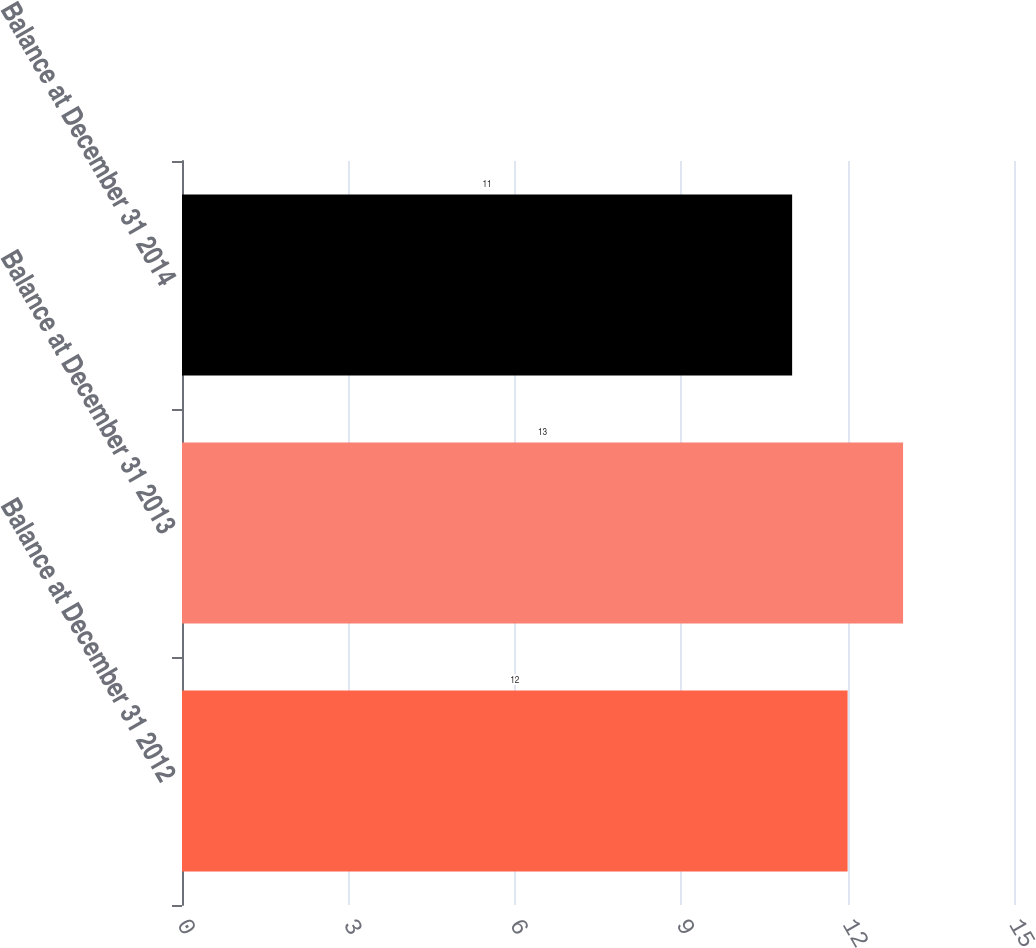<chart> <loc_0><loc_0><loc_500><loc_500><bar_chart><fcel>Balance at December 31 2012<fcel>Balance at December 31 2013<fcel>Balance at December 31 2014<nl><fcel>12<fcel>13<fcel>11<nl></chart> 